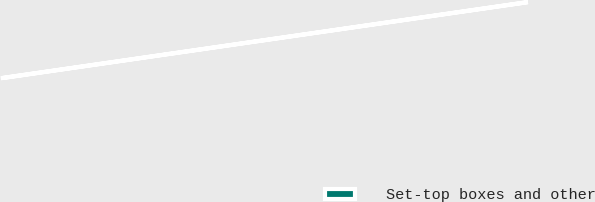<chart> <loc_0><loc_0><loc_500><loc_500><pie_chart><fcel>Set-top boxes and other<nl><fcel>100.0%<nl></chart> 